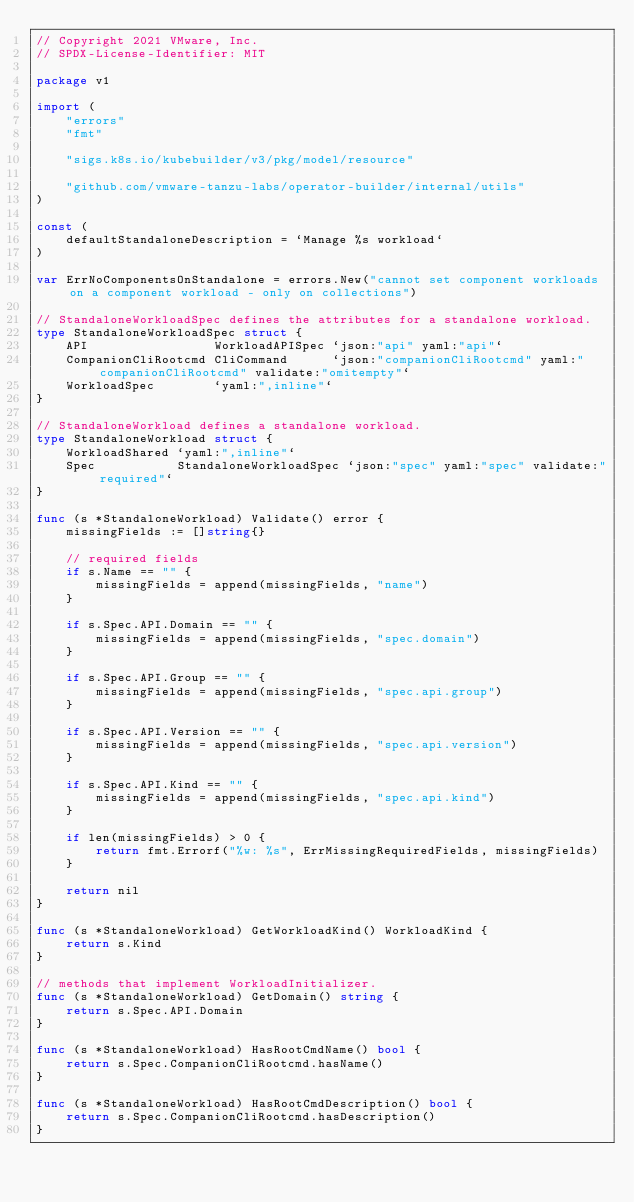<code> <loc_0><loc_0><loc_500><loc_500><_Go_>// Copyright 2021 VMware, Inc.
// SPDX-License-Identifier: MIT

package v1

import (
	"errors"
	"fmt"

	"sigs.k8s.io/kubebuilder/v3/pkg/model/resource"

	"github.com/vmware-tanzu-labs/operator-builder/internal/utils"
)

const (
	defaultStandaloneDescription = `Manage %s workload`
)

var ErrNoComponentsOnStandalone = errors.New("cannot set component workloads on a component workload - only on collections")

// StandaloneWorkloadSpec defines the attributes for a standalone workload.
type StandaloneWorkloadSpec struct {
	API                 WorkloadAPISpec `json:"api" yaml:"api"`
	CompanionCliRootcmd CliCommand      `json:"companionCliRootcmd" yaml:"companionCliRootcmd" validate:"omitempty"`
	WorkloadSpec        `yaml:",inline"`
}

// StandaloneWorkload defines a standalone workload.
type StandaloneWorkload struct {
	WorkloadShared `yaml:",inline"`
	Spec           StandaloneWorkloadSpec `json:"spec" yaml:"spec" validate:"required"`
}

func (s *StandaloneWorkload) Validate() error {
	missingFields := []string{}

	// required fields
	if s.Name == "" {
		missingFields = append(missingFields, "name")
	}

	if s.Spec.API.Domain == "" {
		missingFields = append(missingFields, "spec.domain")
	}

	if s.Spec.API.Group == "" {
		missingFields = append(missingFields, "spec.api.group")
	}

	if s.Spec.API.Version == "" {
		missingFields = append(missingFields, "spec.api.version")
	}

	if s.Spec.API.Kind == "" {
		missingFields = append(missingFields, "spec.api.kind")
	}

	if len(missingFields) > 0 {
		return fmt.Errorf("%w: %s", ErrMissingRequiredFields, missingFields)
	}

	return nil
}

func (s *StandaloneWorkload) GetWorkloadKind() WorkloadKind {
	return s.Kind
}

// methods that implement WorkloadInitializer.
func (s *StandaloneWorkload) GetDomain() string {
	return s.Spec.API.Domain
}

func (s *StandaloneWorkload) HasRootCmdName() bool {
	return s.Spec.CompanionCliRootcmd.hasName()
}

func (s *StandaloneWorkload) HasRootCmdDescription() bool {
	return s.Spec.CompanionCliRootcmd.hasDescription()
}
</code> 